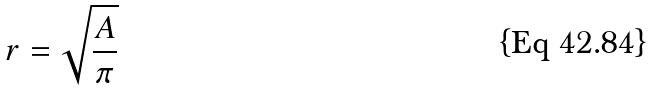Convert formula to latex. <formula><loc_0><loc_0><loc_500><loc_500>r = \sqrt { \frac { A } { \pi } }</formula> 